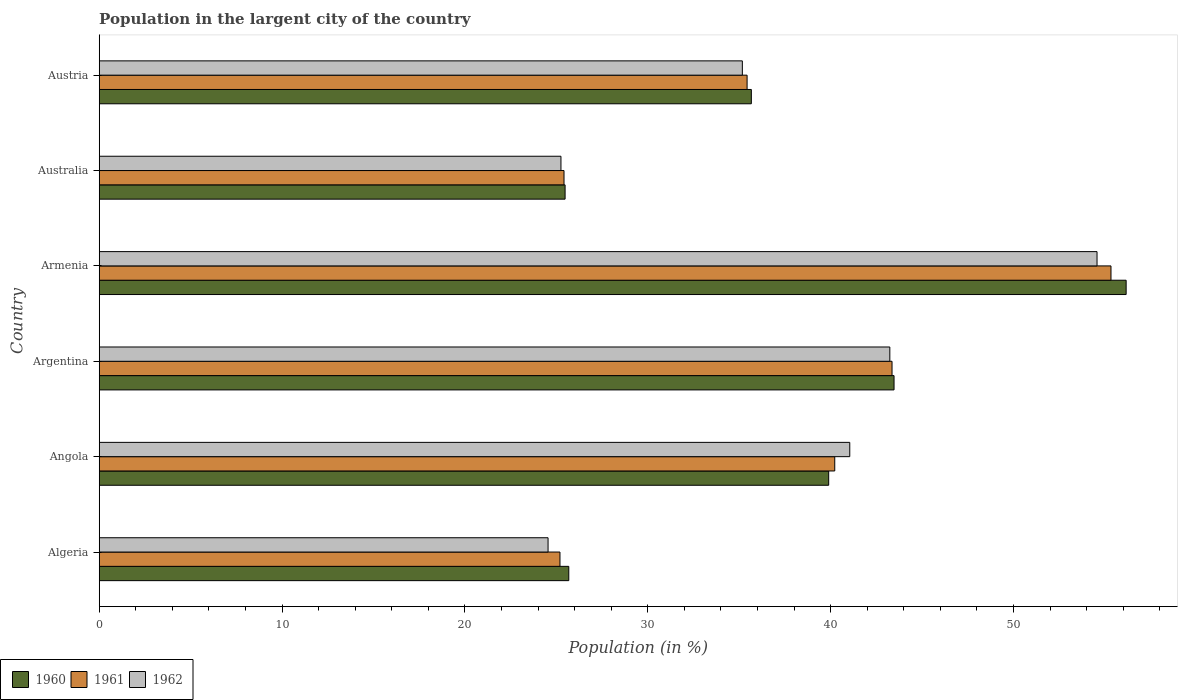How many different coloured bars are there?
Your response must be concise. 3. Are the number of bars per tick equal to the number of legend labels?
Offer a very short reply. Yes. Are the number of bars on each tick of the Y-axis equal?
Give a very brief answer. Yes. How many bars are there on the 1st tick from the bottom?
Your answer should be compact. 3. What is the label of the 5th group of bars from the top?
Offer a terse response. Angola. What is the percentage of population in the largent city in 1962 in Angola?
Your answer should be compact. 41.05. Across all countries, what is the maximum percentage of population in the largent city in 1961?
Ensure brevity in your answer.  55.33. Across all countries, what is the minimum percentage of population in the largent city in 1962?
Your answer should be compact. 24.55. In which country was the percentage of population in the largent city in 1962 maximum?
Give a very brief answer. Armenia. In which country was the percentage of population in the largent city in 1961 minimum?
Make the answer very short. Algeria. What is the total percentage of population in the largent city in 1960 in the graph?
Offer a very short reply. 226.35. What is the difference between the percentage of population in the largent city in 1962 in Angola and that in Armenia?
Your answer should be very brief. -13.52. What is the difference between the percentage of population in the largent city in 1962 in Argentina and the percentage of population in the largent city in 1960 in Algeria?
Offer a very short reply. 17.56. What is the average percentage of population in the largent city in 1962 per country?
Your response must be concise. 37.3. What is the difference between the percentage of population in the largent city in 1961 and percentage of population in the largent city in 1962 in Australia?
Your response must be concise. 0.17. What is the ratio of the percentage of population in the largent city in 1962 in Armenia to that in Austria?
Your answer should be very brief. 1.55. Is the percentage of population in the largent city in 1960 in Argentina less than that in Australia?
Your answer should be very brief. No. What is the difference between the highest and the second highest percentage of population in the largent city in 1961?
Your answer should be compact. 11.97. What is the difference between the highest and the lowest percentage of population in the largent city in 1962?
Make the answer very short. 30.02. Is the sum of the percentage of population in the largent city in 1960 in Argentina and Armenia greater than the maximum percentage of population in the largent city in 1962 across all countries?
Give a very brief answer. Yes. Is it the case that in every country, the sum of the percentage of population in the largent city in 1962 and percentage of population in the largent city in 1960 is greater than the percentage of population in the largent city in 1961?
Make the answer very short. Yes. What is the difference between two consecutive major ticks on the X-axis?
Offer a terse response. 10. How are the legend labels stacked?
Give a very brief answer. Horizontal. What is the title of the graph?
Offer a terse response. Population in the largent city of the country. What is the label or title of the Y-axis?
Keep it short and to the point. Country. What is the Population (in %) of 1960 in Algeria?
Offer a terse response. 25.68. What is the Population (in %) of 1961 in Algeria?
Keep it short and to the point. 25.2. What is the Population (in %) in 1962 in Algeria?
Your response must be concise. 24.55. What is the Population (in %) in 1960 in Angola?
Provide a short and direct response. 39.89. What is the Population (in %) in 1961 in Angola?
Provide a succinct answer. 40.23. What is the Population (in %) of 1962 in Angola?
Make the answer very short. 41.05. What is the Population (in %) of 1960 in Argentina?
Keep it short and to the point. 43.47. What is the Population (in %) in 1961 in Argentina?
Ensure brevity in your answer.  43.36. What is the Population (in %) of 1962 in Argentina?
Give a very brief answer. 43.24. What is the Population (in %) in 1960 in Armenia?
Ensure brevity in your answer.  56.16. What is the Population (in %) of 1961 in Armenia?
Your answer should be very brief. 55.33. What is the Population (in %) of 1962 in Armenia?
Keep it short and to the point. 54.57. What is the Population (in %) of 1960 in Australia?
Give a very brief answer. 25.48. What is the Population (in %) in 1961 in Australia?
Ensure brevity in your answer.  25.42. What is the Population (in %) of 1962 in Australia?
Your response must be concise. 25.25. What is the Population (in %) in 1960 in Austria?
Keep it short and to the point. 35.66. What is the Population (in %) of 1961 in Austria?
Your answer should be compact. 35.43. What is the Population (in %) in 1962 in Austria?
Offer a terse response. 35.17. Across all countries, what is the maximum Population (in %) in 1960?
Offer a terse response. 56.16. Across all countries, what is the maximum Population (in %) of 1961?
Make the answer very short. 55.33. Across all countries, what is the maximum Population (in %) in 1962?
Your answer should be very brief. 54.57. Across all countries, what is the minimum Population (in %) of 1960?
Your response must be concise. 25.48. Across all countries, what is the minimum Population (in %) in 1961?
Keep it short and to the point. 25.2. Across all countries, what is the minimum Population (in %) of 1962?
Your response must be concise. 24.55. What is the total Population (in %) of 1960 in the graph?
Provide a short and direct response. 226.35. What is the total Population (in %) of 1961 in the graph?
Make the answer very short. 224.97. What is the total Population (in %) of 1962 in the graph?
Your answer should be very brief. 223.83. What is the difference between the Population (in %) in 1960 in Algeria and that in Angola?
Provide a succinct answer. -14.21. What is the difference between the Population (in %) of 1961 in Algeria and that in Angola?
Keep it short and to the point. -15.03. What is the difference between the Population (in %) of 1962 in Algeria and that in Angola?
Provide a short and direct response. -16.5. What is the difference between the Population (in %) of 1960 in Algeria and that in Argentina?
Your answer should be compact. -17.79. What is the difference between the Population (in %) in 1961 in Algeria and that in Argentina?
Your answer should be compact. -18.16. What is the difference between the Population (in %) of 1962 in Algeria and that in Argentina?
Your answer should be compact. -18.69. What is the difference between the Population (in %) of 1960 in Algeria and that in Armenia?
Provide a succinct answer. -30.48. What is the difference between the Population (in %) in 1961 in Algeria and that in Armenia?
Make the answer very short. -30.13. What is the difference between the Population (in %) of 1962 in Algeria and that in Armenia?
Your answer should be compact. -30.02. What is the difference between the Population (in %) in 1960 in Algeria and that in Australia?
Your answer should be very brief. 0.2. What is the difference between the Population (in %) of 1961 in Algeria and that in Australia?
Keep it short and to the point. -0.22. What is the difference between the Population (in %) of 1962 in Algeria and that in Australia?
Offer a very short reply. -0.71. What is the difference between the Population (in %) in 1960 in Algeria and that in Austria?
Provide a succinct answer. -9.98. What is the difference between the Population (in %) of 1961 in Algeria and that in Austria?
Make the answer very short. -10.23. What is the difference between the Population (in %) in 1962 in Algeria and that in Austria?
Your response must be concise. -10.63. What is the difference between the Population (in %) in 1960 in Angola and that in Argentina?
Your answer should be very brief. -3.57. What is the difference between the Population (in %) of 1961 in Angola and that in Argentina?
Ensure brevity in your answer.  -3.13. What is the difference between the Population (in %) in 1962 in Angola and that in Argentina?
Make the answer very short. -2.19. What is the difference between the Population (in %) of 1960 in Angola and that in Armenia?
Keep it short and to the point. -16.27. What is the difference between the Population (in %) in 1961 in Angola and that in Armenia?
Give a very brief answer. -15.11. What is the difference between the Population (in %) in 1962 in Angola and that in Armenia?
Make the answer very short. -13.52. What is the difference between the Population (in %) of 1960 in Angola and that in Australia?
Provide a short and direct response. 14.42. What is the difference between the Population (in %) of 1961 in Angola and that in Australia?
Ensure brevity in your answer.  14.81. What is the difference between the Population (in %) of 1962 in Angola and that in Australia?
Your response must be concise. 15.8. What is the difference between the Population (in %) in 1960 in Angola and that in Austria?
Offer a terse response. 4.23. What is the difference between the Population (in %) of 1961 in Angola and that in Austria?
Keep it short and to the point. 4.79. What is the difference between the Population (in %) in 1962 in Angola and that in Austria?
Offer a terse response. 5.87. What is the difference between the Population (in %) of 1960 in Argentina and that in Armenia?
Offer a very short reply. -12.69. What is the difference between the Population (in %) in 1961 in Argentina and that in Armenia?
Your answer should be compact. -11.97. What is the difference between the Population (in %) of 1962 in Argentina and that in Armenia?
Your answer should be compact. -11.33. What is the difference between the Population (in %) in 1960 in Argentina and that in Australia?
Give a very brief answer. 17.99. What is the difference between the Population (in %) in 1961 in Argentina and that in Australia?
Offer a very short reply. 17.94. What is the difference between the Population (in %) of 1962 in Argentina and that in Australia?
Offer a terse response. 17.99. What is the difference between the Population (in %) in 1960 in Argentina and that in Austria?
Ensure brevity in your answer.  7.8. What is the difference between the Population (in %) in 1961 in Argentina and that in Austria?
Your answer should be compact. 7.93. What is the difference between the Population (in %) in 1962 in Argentina and that in Austria?
Provide a short and direct response. 8.07. What is the difference between the Population (in %) of 1960 in Armenia and that in Australia?
Provide a short and direct response. 30.68. What is the difference between the Population (in %) in 1961 in Armenia and that in Australia?
Provide a succinct answer. 29.91. What is the difference between the Population (in %) of 1962 in Armenia and that in Australia?
Your answer should be very brief. 29.32. What is the difference between the Population (in %) in 1960 in Armenia and that in Austria?
Provide a short and direct response. 20.5. What is the difference between the Population (in %) in 1961 in Armenia and that in Austria?
Keep it short and to the point. 19.9. What is the difference between the Population (in %) in 1962 in Armenia and that in Austria?
Ensure brevity in your answer.  19.4. What is the difference between the Population (in %) in 1960 in Australia and that in Austria?
Your answer should be very brief. -10.19. What is the difference between the Population (in %) of 1961 in Australia and that in Austria?
Your answer should be very brief. -10.01. What is the difference between the Population (in %) in 1962 in Australia and that in Austria?
Offer a terse response. -9.92. What is the difference between the Population (in %) of 1960 in Algeria and the Population (in %) of 1961 in Angola?
Offer a very short reply. -14.55. What is the difference between the Population (in %) of 1960 in Algeria and the Population (in %) of 1962 in Angola?
Make the answer very short. -15.37. What is the difference between the Population (in %) in 1961 in Algeria and the Population (in %) in 1962 in Angola?
Offer a terse response. -15.85. What is the difference between the Population (in %) of 1960 in Algeria and the Population (in %) of 1961 in Argentina?
Provide a short and direct response. -17.68. What is the difference between the Population (in %) in 1960 in Algeria and the Population (in %) in 1962 in Argentina?
Provide a succinct answer. -17.56. What is the difference between the Population (in %) of 1961 in Algeria and the Population (in %) of 1962 in Argentina?
Give a very brief answer. -18.04. What is the difference between the Population (in %) of 1960 in Algeria and the Population (in %) of 1961 in Armenia?
Offer a very short reply. -29.65. What is the difference between the Population (in %) of 1960 in Algeria and the Population (in %) of 1962 in Armenia?
Make the answer very short. -28.89. What is the difference between the Population (in %) in 1961 in Algeria and the Population (in %) in 1962 in Armenia?
Offer a very short reply. -29.37. What is the difference between the Population (in %) of 1960 in Algeria and the Population (in %) of 1961 in Australia?
Make the answer very short. 0.26. What is the difference between the Population (in %) in 1960 in Algeria and the Population (in %) in 1962 in Australia?
Ensure brevity in your answer.  0.43. What is the difference between the Population (in %) in 1961 in Algeria and the Population (in %) in 1962 in Australia?
Give a very brief answer. -0.05. What is the difference between the Population (in %) in 1960 in Algeria and the Population (in %) in 1961 in Austria?
Offer a very short reply. -9.75. What is the difference between the Population (in %) of 1960 in Algeria and the Population (in %) of 1962 in Austria?
Offer a terse response. -9.49. What is the difference between the Population (in %) in 1961 in Algeria and the Population (in %) in 1962 in Austria?
Keep it short and to the point. -9.97. What is the difference between the Population (in %) in 1960 in Angola and the Population (in %) in 1961 in Argentina?
Keep it short and to the point. -3.46. What is the difference between the Population (in %) of 1960 in Angola and the Population (in %) of 1962 in Argentina?
Your answer should be compact. -3.34. What is the difference between the Population (in %) of 1961 in Angola and the Population (in %) of 1962 in Argentina?
Offer a terse response. -3.01. What is the difference between the Population (in %) of 1960 in Angola and the Population (in %) of 1961 in Armenia?
Your response must be concise. -15.44. What is the difference between the Population (in %) of 1960 in Angola and the Population (in %) of 1962 in Armenia?
Offer a terse response. -14.68. What is the difference between the Population (in %) in 1961 in Angola and the Population (in %) in 1962 in Armenia?
Ensure brevity in your answer.  -14.34. What is the difference between the Population (in %) of 1960 in Angola and the Population (in %) of 1961 in Australia?
Your answer should be very brief. 14.48. What is the difference between the Population (in %) in 1960 in Angola and the Population (in %) in 1962 in Australia?
Your answer should be very brief. 14.64. What is the difference between the Population (in %) in 1961 in Angola and the Population (in %) in 1962 in Australia?
Provide a succinct answer. 14.97. What is the difference between the Population (in %) in 1960 in Angola and the Population (in %) in 1961 in Austria?
Provide a short and direct response. 4.46. What is the difference between the Population (in %) of 1960 in Angola and the Population (in %) of 1962 in Austria?
Give a very brief answer. 4.72. What is the difference between the Population (in %) in 1961 in Angola and the Population (in %) in 1962 in Austria?
Ensure brevity in your answer.  5.05. What is the difference between the Population (in %) in 1960 in Argentina and the Population (in %) in 1961 in Armenia?
Provide a short and direct response. -11.86. What is the difference between the Population (in %) in 1960 in Argentina and the Population (in %) in 1962 in Armenia?
Give a very brief answer. -11.1. What is the difference between the Population (in %) in 1961 in Argentina and the Population (in %) in 1962 in Armenia?
Offer a very short reply. -11.21. What is the difference between the Population (in %) of 1960 in Argentina and the Population (in %) of 1961 in Australia?
Offer a very short reply. 18.05. What is the difference between the Population (in %) in 1960 in Argentina and the Population (in %) in 1962 in Australia?
Provide a short and direct response. 18.22. What is the difference between the Population (in %) of 1961 in Argentina and the Population (in %) of 1962 in Australia?
Ensure brevity in your answer.  18.11. What is the difference between the Population (in %) in 1960 in Argentina and the Population (in %) in 1961 in Austria?
Provide a succinct answer. 8.04. What is the difference between the Population (in %) of 1960 in Argentina and the Population (in %) of 1962 in Austria?
Provide a succinct answer. 8.3. What is the difference between the Population (in %) in 1961 in Argentina and the Population (in %) in 1962 in Austria?
Provide a short and direct response. 8.19. What is the difference between the Population (in %) in 1960 in Armenia and the Population (in %) in 1961 in Australia?
Provide a succinct answer. 30.74. What is the difference between the Population (in %) of 1960 in Armenia and the Population (in %) of 1962 in Australia?
Provide a succinct answer. 30.91. What is the difference between the Population (in %) of 1961 in Armenia and the Population (in %) of 1962 in Australia?
Ensure brevity in your answer.  30.08. What is the difference between the Population (in %) in 1960 in Armenia and the Population (in %) in 1961 in Austria?
Give a very brief answer. 20.73. What is the difference between the Population (in %) in 1960 in Armenia and the Population (in %) in 1962 in Austria?
Your response must be concise. 20.99. What is the difference between the Population (in %) of 1961 in Armenia and the Population (in %) of 1962 in Austria?
Your response must be concise. 20.16. What is the difference between the Population (in %) in 1960 in Australia and the Population (in %) in 1961 in Austria?
Provide a short and direct response. -9.95. What is the difference between the Population (in %) of 1960 in Australia and the Population (in %) of 1962 in Austria?
Provide a succinct answer. -9.69. What is the difference between the Population (in %) in 1961 in Australia and the Population (in %) in 1962 in Austria?
Offer a terse response. -9.75. What is the average Population (in %) of 1960 per country?
Keep it short and to the point. 37.72. What is the average Population (in %) in 1961 per country?
Make the answer very short. 37.49. What is the average Population (in %) of 1962 per country?
Give a very brief answer. 37.3. What is the difference between the Population (in %) in 1960 and Population (in %) in 1961 in Algeria?
Provide a short and direct response. 0.48. What is the difference between the Population (in %) in 1960 and Population (in %) in 1962 in Algeria?
Keep it short and to the point. 1.13. What is the difference between the Population (in %) of 1961 and Population (in %) of 1962 in Algeria?
Your answer should be compact. 0.65. What is the difference between the Population (in %) in 1960 and Population (in %) in 1961 in Angola?
Ensure brevity in your answer.  -0.33. What is the difference between the Population (in %) in 1960 and Population (in %) in 1962 in Angola?
Keep it short and to the point. -1.15. What is the difference between the Population (in %) of 1961 and Population (in %) of 1962 in Angola?
Provide a short and direct response. -0.82. What is the difference between the Population (in %) of 1960 and Population (in %) of 1961 in Argentina?
Give a very brief answer. 0.11. What is the difference between the Population (in %) of 1960 and Population (in %) of 1962 in Argentina?
Give a very brief answer. 0.23. What is the difference between the Population (in %) of 1961 and Population (in %) of 1962 in Argentina?
Keep it short and to the point. 0.12. What is the difference between the Population (in %) of 1960 and Population (in %) of 1961 in Armenia?
Give a very brief answer. 0.83. What is the difference between the Population (in %) of 1960 and Population (in %) of 1962 in Armenia?
Your answer should be very brief. 1.59. What is the difference between the Population (in %) of 1961 and Population (in %) of 1962 in Armenia?
Your answer should be very brief. 0.76. What is the difference between the Population (in %) in 1960 and Population (in %) in 1961 in Australia?
Keep it short and to the point. 0.06. What is the difference between the Population (in %) in 1960 and Population (in %) in 1962 in Australia?
Offer a terse response. 0.23. What is the difference between the Population (in %) of 1961 and Population (in %) of 1962 in Australia?
Give a very brief answer. 0.17. What is the difference between the Population (in %) in 1960 and Population (in %) in 1961 in Austria?
Offer a terse response. 0.23. What is the difference between the Population (in %) in 1960 and Population (in %) in 1962 in Austria?
Your answer should be very brief. 0.49. What is the difference between the Population (in %) in 1961 and Population (in %) in 1962 in Austria?
Ensure brevity in your answer.  0.26. What is the ratio of the Population (in %) of 1960 in Algeria to that in Angola?
Offer a very short reply. 0.64. What is the ratio of the Population (in %) in 1961 in Algeria to that in Angola?
Keep it short and to the point. 0.63. What is the ratio of the Population (in %) in 1962 in Algeria to that in Angola?
Your answer should be compact. 0.6. What is the ratio of the Population (in %) of 1960 in Algeria to that in Argentina?
Offer a terse response. 0.59. What is the ratio of the Population (in %) of 1961 in Algeria to that in Argentina?
Keep it short and to the point. 0.58. What is the ratio of the Population (in %) of 1962 in Algeria to that in Argentina?
Offer a very short reply. 0.57. What is the ratio of the Population (in %) in 1960 in Algeria to that in Armenia?
Give a very brief answer. 0.46. What is the ratio of the Population (in %) in 1961 in Algeria to that in Armenia?
Ensure brevity in your answer.  0.46. What is the ratio of the Population (in %) in 1962 in Algeria to that in Armenia?
Your response must be concise. 0.45. What is the ratio of the Population (in %) of 1960 in Algeria to that in Australia?
Provide a succinct answer. 1.01. What is the ratio of the Population (in %) in 1962 in Algeria to that in Australia?
Make the answer very short. 0.97. What is the ratio of the Population (in %) of 1960 in Algeria to that in Austria?
Offer a very short reply. 0.72. What is the ratio of the Population (in %) in 1961 in Algeria to that in Austria?
Make the answer very short. 0.71. What is the ratio of the Population (in %) of 1962 in Algeria to that in Austria?
Your answer should be compact. 0.7. What is the ratio of the Population (in %) in 1960 in Angola to that in Argentina?
Your response must be concise. 0.92. What is the ratio of the Population (in %) in 1961 in Angola to that in Argentina?
Offer a very short reply. 0.93. What is the ratio of the Population (in %) in 1962 in Angola to that in Argentina?
Offer a terse response. 0.95. What is the ratio of the Population (in %) in 1960 in Angola to that in Armenia?
Offer a very short reply. 0.71. What is the ratio of the Population (in %) of 1961 in Angola to that in Armenia?
Offer a terse response. 0.73. What is the ratio of the Population (in %) in 1962 in Angola to that in Armenia?
Give a very brief answer. 0.75. What is the ratio of the Population (in %) in 1960 in Angola to that in Australia?
Keep it short and to the point. 1.57. What is the ratio of the Population (in %) in 1961 in Angola to that in Australia?
Offer a very short reply. 1.58. What is the ratio of the Population (in %) of 1962 in Angola to that in Australia?
Keep it short and to the point. 1.63. What is the ratio of the Population (in %) in 1960 in Angola to that in Austria?
Offer a very short reply. 1.12. What is the ratio of the Population (in %) of 1961 in Angola to that in Austria?
Ensure brevity in your answer.  1.14. What is the ratio of the Population (in %) of 1962 in Angola to that in Austria?
Provide a short and direct response. 1.17. What is the ratio of the Population (in %) of 1960 in Argentina to that in Armenia?
Give a very brief answer. 0.77. What is the ratio of the Population (in %) in 1961 in Argentina to that in Armenia?
Your answer should be very brief. 0.78. What is the ratio of the Population (in %) of 1962 in Argentina to that in Armenia?
Your answer should be compact. 0.79. What is the ratio of the Population (in %) in 1960 in Argentina to that in Australia?
Your response must be concise. 1.71. What is the ratio of the Population (in %) in 1961 in Argentina to that in Australia?
Your response must be concise. 1.71. What is the ratio of the Population (in %) of 1962 in Argentina to that in Australia?
Your response must be concise. 1.71. What is the ratio of the Population (in %) in 1960 in Argentina to that in Austria?
Offer a very short reply. 1.22. What is the ratio of the Population (in %) of 1961 in Argentina to that in Austria?
Give a very brief answer. 1.22. What is the ratio of the Population (in %) in 1962 in Argentina to that in Austria?
Provide a succinct answer. 1.23. What is the ratio of the Population (in %) in 1960 in Armenia to that in Australia?
Your response must be concise. 2.2. What is the ratio of the Population (in %) of 1961 in Armenia to that in Australia?
Provide a short and direct response. 2.18. What is the ratio of the Population (in %) in 1962 in Armenia to that in Australia?
Provide a short and direct response. 2.16. What is the ratio of the Population (in %) of 1960 in Armenia to that in Austria?
Provide a succinct answer. 1.57. What is the ratio of the Population (in %) of 1961 in Armenia to that in Austria?
Your answer should be very brief. 1.56. What is the ratio of the Population (in %) in 1962 in Armenia to that in Austria?
Keep it short and to the point. 1.55. What is the ratio of the Population (in %) of 1960 in Australia to that in Austria?
Your answer should be very brief. 0.71. What is the ratio of the Population (in %) in 1961 in Australia to that in Austria?
Your response must be concise. 0.72. What is the ratio of the Population (in %) in 1962 in Australia to that in Austria?
Make the answer very short. 0.72. What is the difference between the highest and the second highest Population (in %) in 1960?
Provide a short and direct response. 12.69. What is the difference between the highest and the second highest Population (in %) in 1961?
Offer a very short reply. 11.97. What is the difference between the highest and the second highest Population (in %) of 1962?
Your response must be concise. 11.33. What is the difference between the highest and the lowest Population (in %) in 1960?
Your answer should be compact. 30.68. What is the difference between the highest and the lowest Population (in %) in 1961?
Offer a terse response. 30.13. What is the difference between the highest and the lowest Population (in %) of 1962?
Your response must be concise. 30.02. 